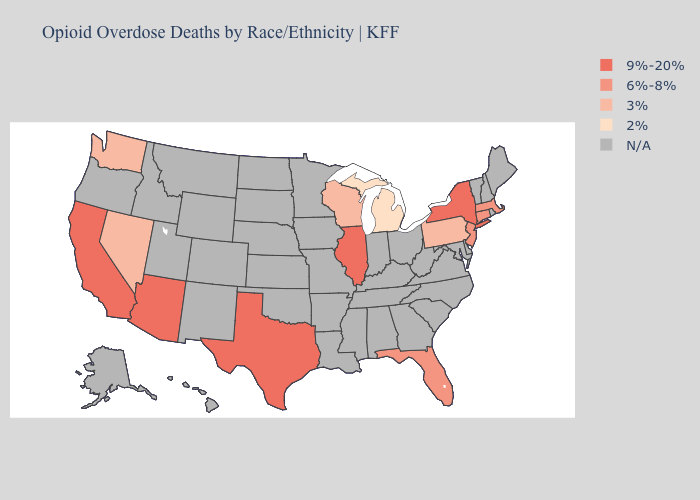Does Wisconsin have the lowest value in the USA?
Keep it brief. No. Name the states that have a value in the range N/A?
Concise answer only. Alabama, Alaska, Arkansas, Colorado, Delaware, Georgia, Hawaii, Idaho, Indiana, Iowa, Kansas, Kentucky, Louisiana, Maine, Maryland, Minnesota, Mississippi, Missouri, Montana, Nebraska, New Hampshire, New Mexico, North Carolina, North Dakota, Ohio, Oklahoma, Oregon, Rhode Island, South Carolina, South Dakota, Tennessee, Utah, Vermont, Virginia, West Virginia, Wyoming. Name the states that have a value in the range 2%?
Give a very brief answer. Michigan. Does New York have the lowest value in the Northeast?
Quick response, please. No. What is the value of Montana?
Concise answer only. N/A. Among the states that border Missouri , which have the highest value?
Keep it brief. Illinois. Does the first symbol in the legend represent the smallest category?
Short answer required. No. What is the value of Pennsylvania?
Write a very short answer. 3%. Does the map have missing data?
Concise answer only. Yes. Does the map have missing data?
Write a very short answer. Yes. Name the states that have a value in the range N/A?
Be succinct. Alabama, Alaska, Arkansas, Colorado, Delaware, Georgia, Hawaii, Idaho, Indiana, Iowa, Kansas, Kentucky, Louisiana, Maine, Maryland, Minnesota, Mississippi, Missouri, Montana, Nebraska, New Hampshire, New Mexico, North Carolina, North Dakota, Ohio, Oklahoma, Oregon, Rhode Island, South Carolina, South Dakota, Tennessee, Utah, Vermont, Virginia, West Virginia, Wyoming. 